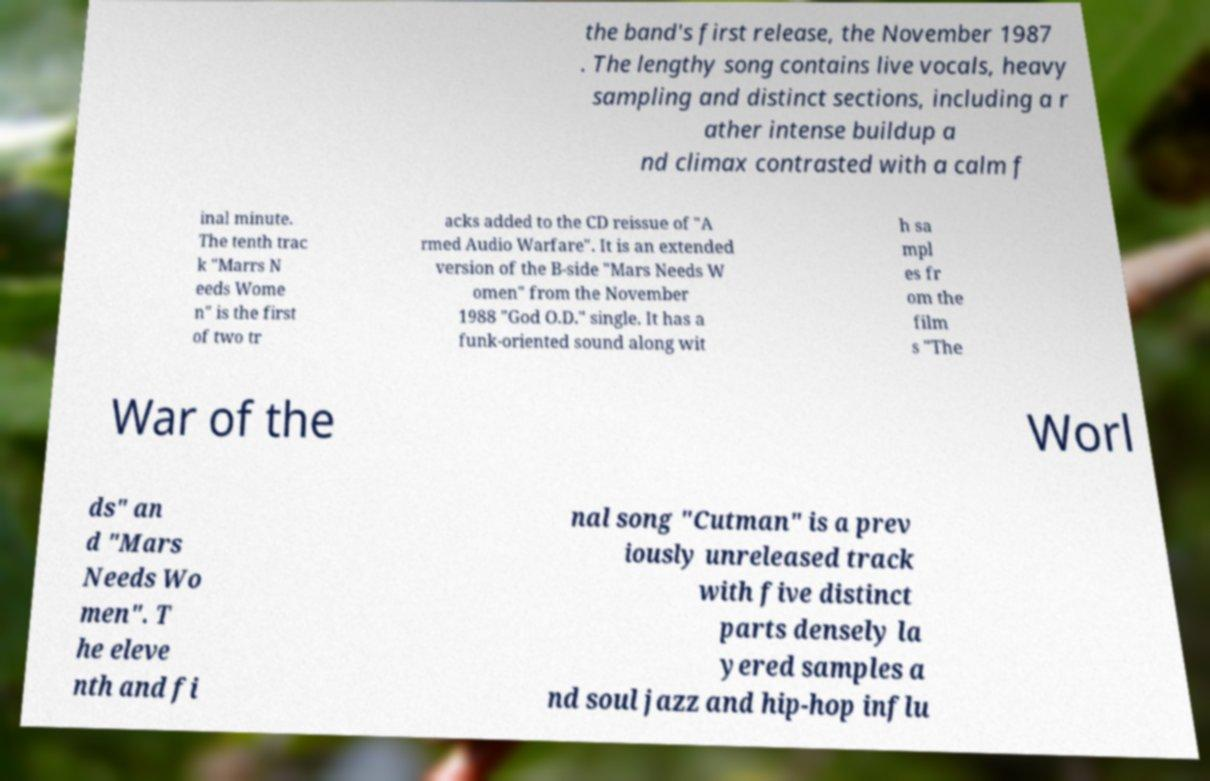Can you accurately transcribe the text from the provided image for me? the band's first release, the November 1987 . The lengthy song contains live vocals, heavy sampling and distinct sections, including a r ather intense buildup a nd climax contrasted with a calm f inal minute. The tenth trac k "Marrs N eeds Wome n" is the first of two tr acks added to the CD reissue of "A rmed Audio Warfare". It is an extended version of the B-side "Mars Needs W omen" from the November 1988 "God O.D." single. It has a funk-oriented sound along wit h sa mpl es fr om the film s "The War of the Worl ds" an d "Mars Needs Wo men". T he eleve nth and fi nal song "Cutman" is a prev iously unreleased track with five distinct parts densely la yered samples a nd soul jazz and hip-hop influ 